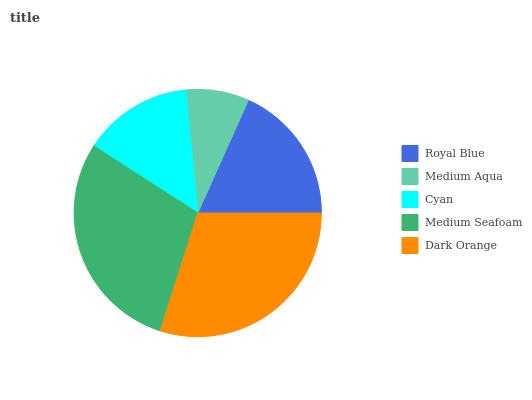Is Medium Aqua the minimum?
Answer yes or no. Yes. Is Dark Orange the maximum?
Answer yes or no. Yes. Is Cyan the minimum?
Answer yes or no. No. Is Cyan the maximum?
Answer yes or no. No. Is Cyan greater than Medium Aqua?
Answer yes or no. Yes. Is Medium Aqua less than Cyan?
Answer yes or no. Yes. Is Medium Aqua greater than Cyan?
Answer yes or no. No. Is Cyan less than Medium Aqua?
Answer yes or no. No. Is Royal Blue the high median?
Answer yes or no. Yes. Is Royal Blue the low median?
Answer yes or no. Yes. Is Medium Aqua the high median?
Answer yes or no. No. Is Dark Orange the low median?
Answer yes or no. No. 